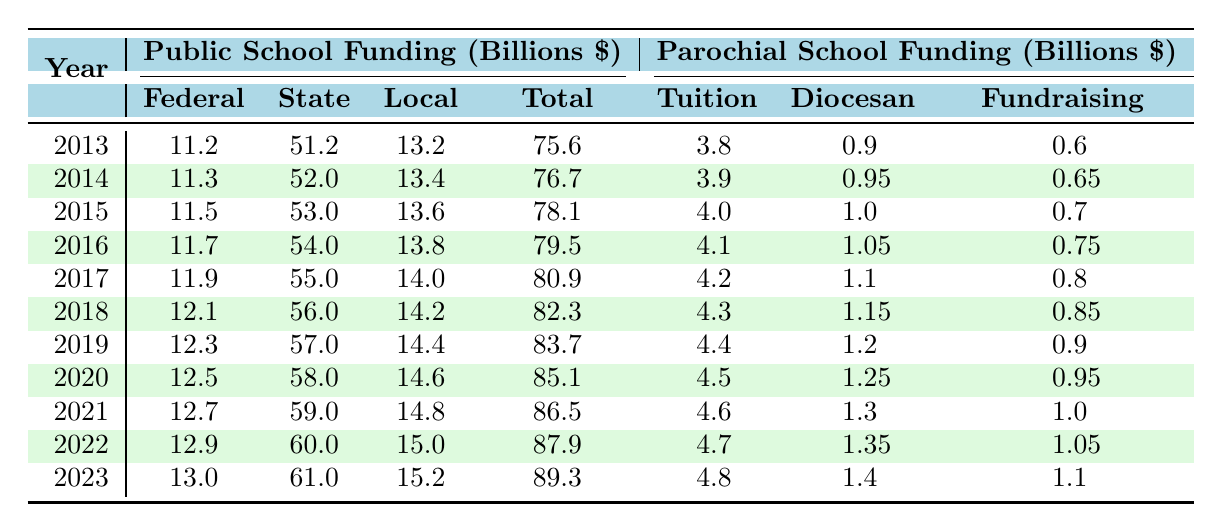What was the total funding for public schools in 2023? Referring to the table, in 2023, the total funding for public schools is listed as 89.3 billion dollars.
Answer: 89.3 billion dollars How much funding did parochial schools receive from tuition in 2020? The table shows that in 2020, parochial schools received 4.5 billion dollars from tuition.
Answer: 4.5 billion dollars What is the average federal funding for public schools over the last decade (from 2013 to 2023)? The federal funding values over the years are: 11.2, 11.3, 11.5, 11.7, 11.9, 12.1, 12.3, 12.5, 12.7, 12.9, and 13.0 billion dollars (11.2 + 11.3 + 11.5 + 11.7 + 11.9 + 12.1 + 12.3 + 12.5 + 12.7 + 12.9 + 13.0 = 139.1). Dividing by 11 (years) gives the average of approximately 12.64 billion dollars.
Answer: 12.64 billion dollars Which year saw the highest total funding for parochial schools? Looking at the total funding for parochial schools across the years, 2023 has the highest value of 7.3 billion dollars compared to other years.
Answer: 2023 Did state funding for public schools increase every year from 2013 to 2023? The table shows a consistent year-over-year increase in state funding: 51.2, 52.0, 53.0, 54.0, 55.0, 56.0, 57.0, 58.0, 59.0, 60.0, and 61.0 billion dollars. Therefore, yes, state funding increased every year.
Answer: Yes What was the percentage increase in total funding for public schools from 2013 to 2023? The total funding for public schools in 2013 was 75.6 billion dollars, and in 2023 it was 89.3 billion dollars. The increase is (89.3 - 75.6) = 13.7 billion dollars. To find the percentage increase: (13.7 / 75.6) * 100 = 18.13%.
Answer: 18.13% What was the difference between local funding of public schools and diocesan support for parochial schools in 2015? In 2015, local funding for public schools was 13.6 billion dollars, and diocesan support for parochial schools was 1.0 billion dollars. The difference is 13.6 - 1.0 = 12.6 billion dollars.
Answer: 12.6 billion dollars How did the total funding for parochial schools change from 2013 to 2022? In 2013, the total funding for parochial schools was 5.3 billion dollars and in 2022 it was 7.1 billion dollars. Thus, the change is 7.1 - 5.3 = 1.8 billion dollars, indicating an increase over the years.
Answer: Increased by 1.8 billion dollars In which year did public school federal funding first exceed 12 billion dollars? The table shows public school federal funding exceeded 12 billion dollars for the first time in 2016, when it was 11.7 billion dollars, and continued to increase thereafter.
Answer: 2016 What is the trend in fundraising for parochial schools from 2013 to 2023? Reviewing the fundraising figures shows consistent growth from 0.6 billion in 2013 to 1.1 billion in 2023, indicating an upward trend in fundraising for parochial schools over the decade.
Answer: Upward trend 